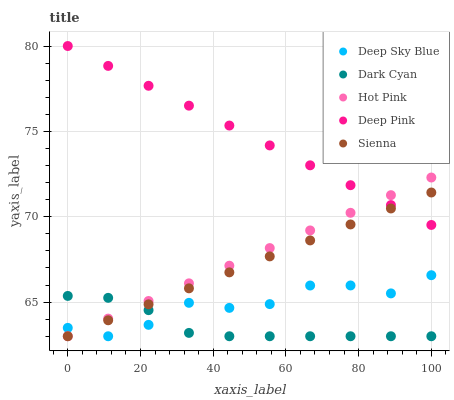Does Dark Cyan have the minimum area under the curve?
Answer yes or no. Yes. Does Deep Pink have the maximum area under the curve?
Answer yes or no. Yes. Does Sienna have the minimum area under the curve?
Answer yes or no. No. Does Sienna have the maximum area under the curve?
Answer yes or no. No. Is Hot Pink the smoothest?
Answer yes or no. Yes. Is Deep Sky Blue the roughest?
Answer yes or no. Yes. Is Sienna the smoothest?
Answer yes or no. No. Is Sienna the roughest?
Answer yes or no. No. Does Dark Cyan have the lowest value?
Answer yes or no. Yes. Does Deep Pink have the lowest value?
Answer yes or no. No. Does Deep Pink have the highest value?
Answer yes or no. Yes. Does Sienna have the highest value?
Answer yes or no. No. Is Dark Cyan less than Deep Pink?
Answer yes or no. Yes. Is Deep Pink greater than Dark Cyan?
Answer yes or no. Yes. Does Deep Pink intersect Hot Pink?
Answer yes or no. Yes. Is Deep Pink less than Hot Pink?
Answer yes or no. No. Is Deep Pink greater than Hot Pink?
Answer yes or no. No. Does Dark Cyan intersect Deep Pink?
Answer yes or no. No. 